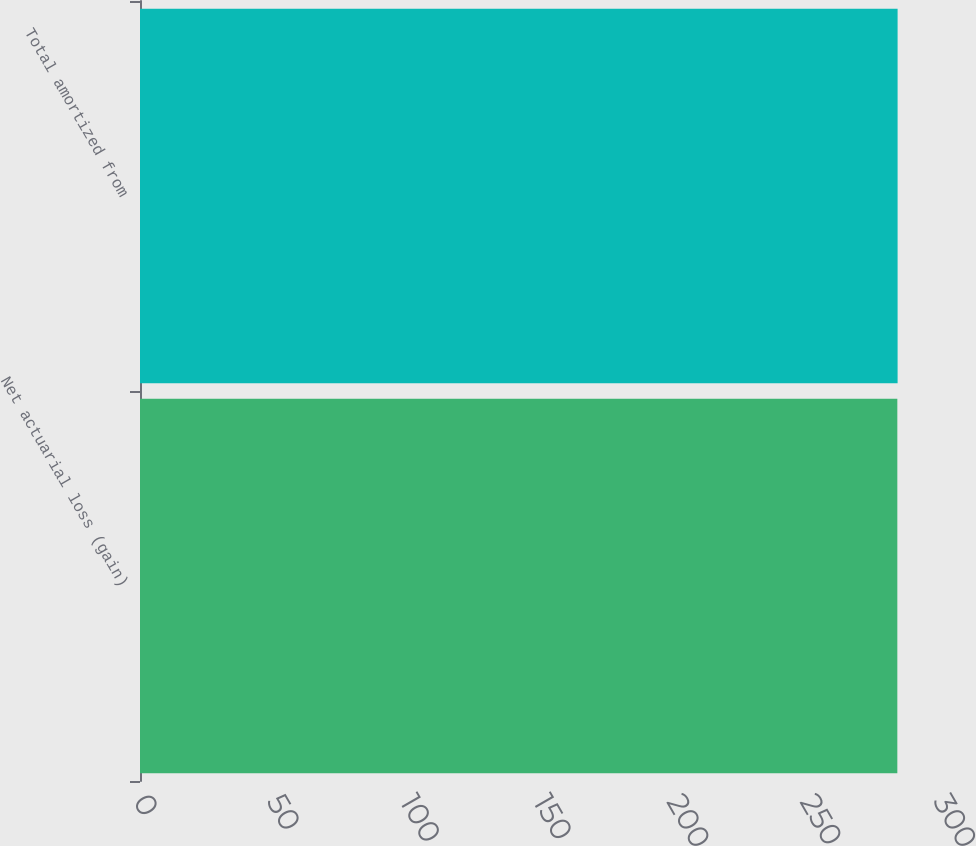Convert chart to OTSL. <chart><loc_0><loc_0><loc_500><loc_500><bar_chart><fcel>Net actuarial loss (gain)<fcel>Total amortized from<nl><fcel>284<fcel>284.1<nl></chart> 